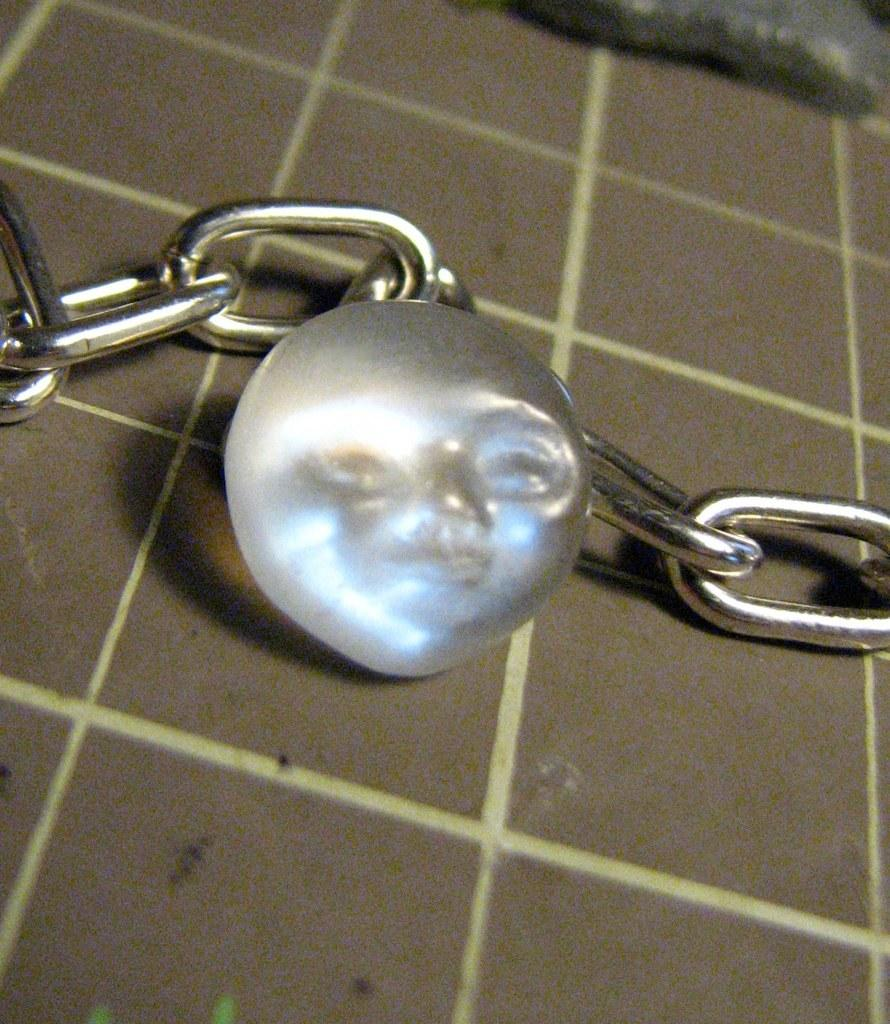What is the main object in the image? The main object in the image is a metal chain. How is the metal chain positioned in the image? The metal chain is placed on a board. What is attached to the metal chain? There is a locket on the metal chain. What does the locket resemble? The locket resembles a person's face. What type of star can be seen shining brightly in the image? There is no star visible in the image; it features a metal chain with a locket resembling a person's face. Can you tell me how many clams are present in the image? There are no clams present in the image; it features a metal chain with a locket resembling a person's face. 